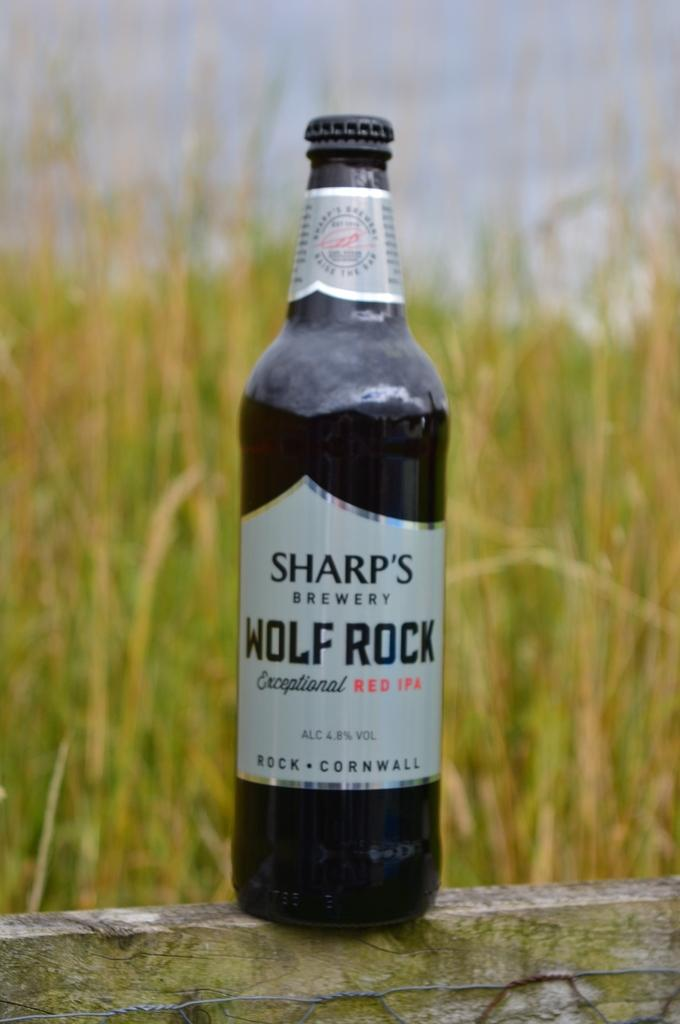What is in the glass bottle that is visible in the image? There is a glass bottle with labels in the image. What type of natural environment is visible in the background of the image? There is grass in the background of the image. What is visible in the sky in the background of the image? The sky is visible in the background of the image. Can you describe the texture of the can in the image? There is no can present in the image; it features a glass bottle with labels. What type of request is being made in the image? There is no request being made in the image; it simply shows a glass bottle with labels against a background of grass and sky. 